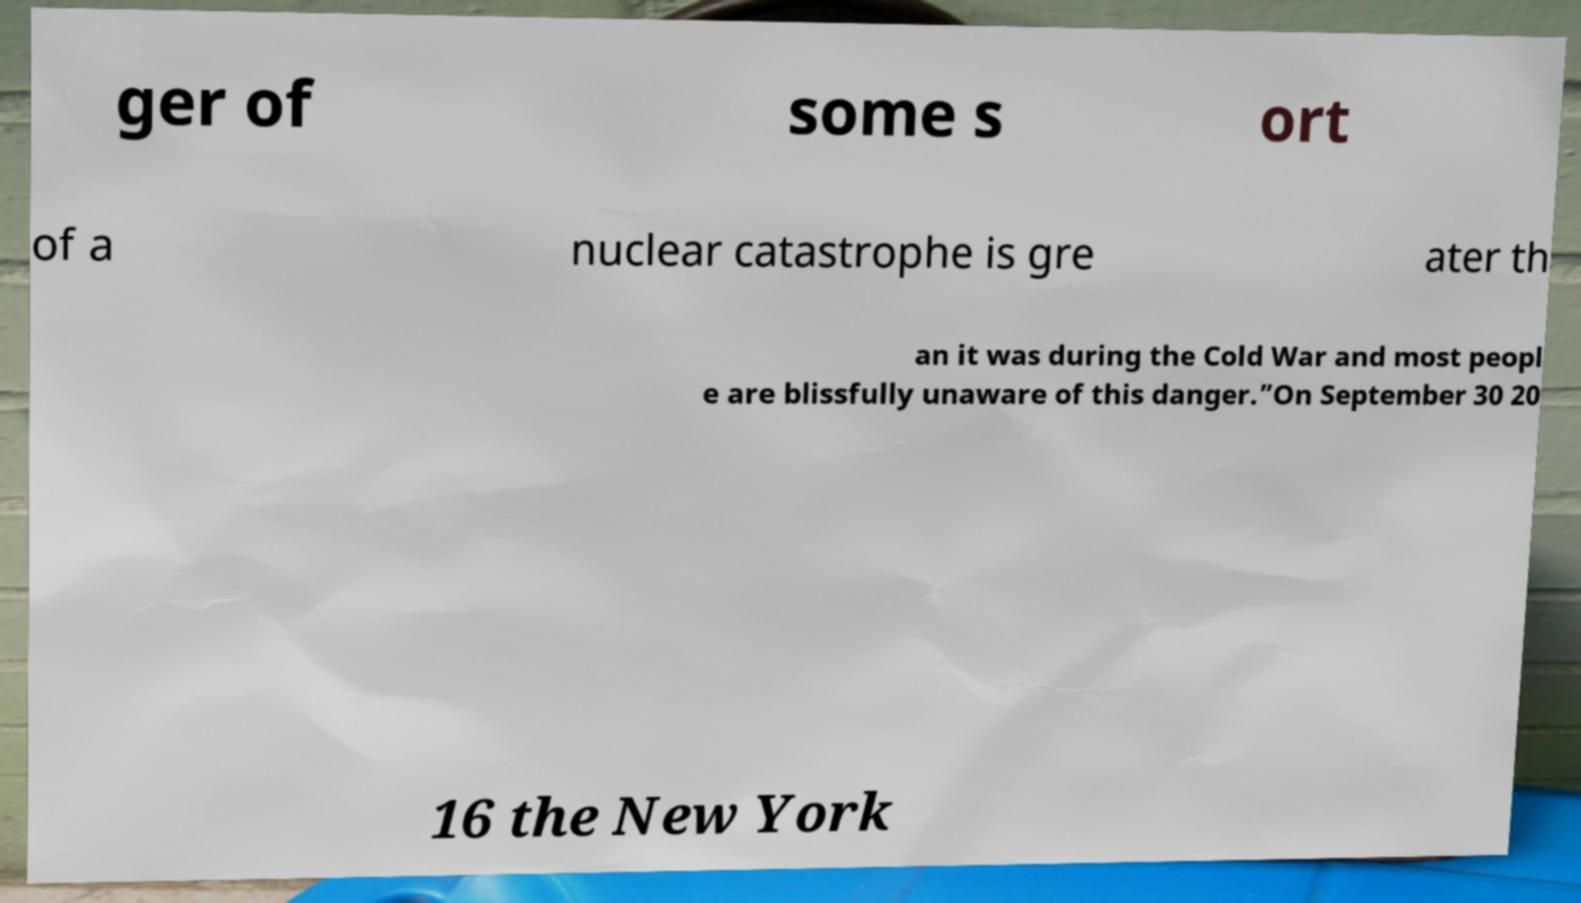Please identify and transcribe the text found in this image. ger of some s ort of a nuclear catastrophe is gre ater th an it was during the Cold War and most peopl e are blissfully unaware of this danger.”On September 30 20 16 the New York 